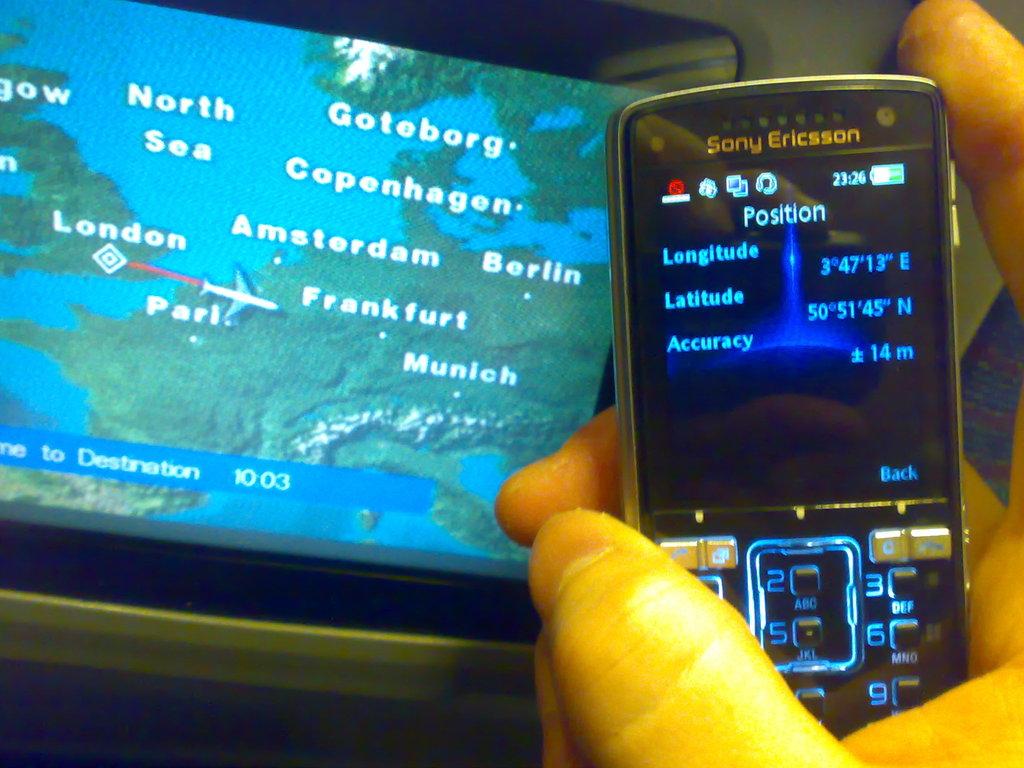What is the name of one city on the screen?
Make the answer very short. Munich. 